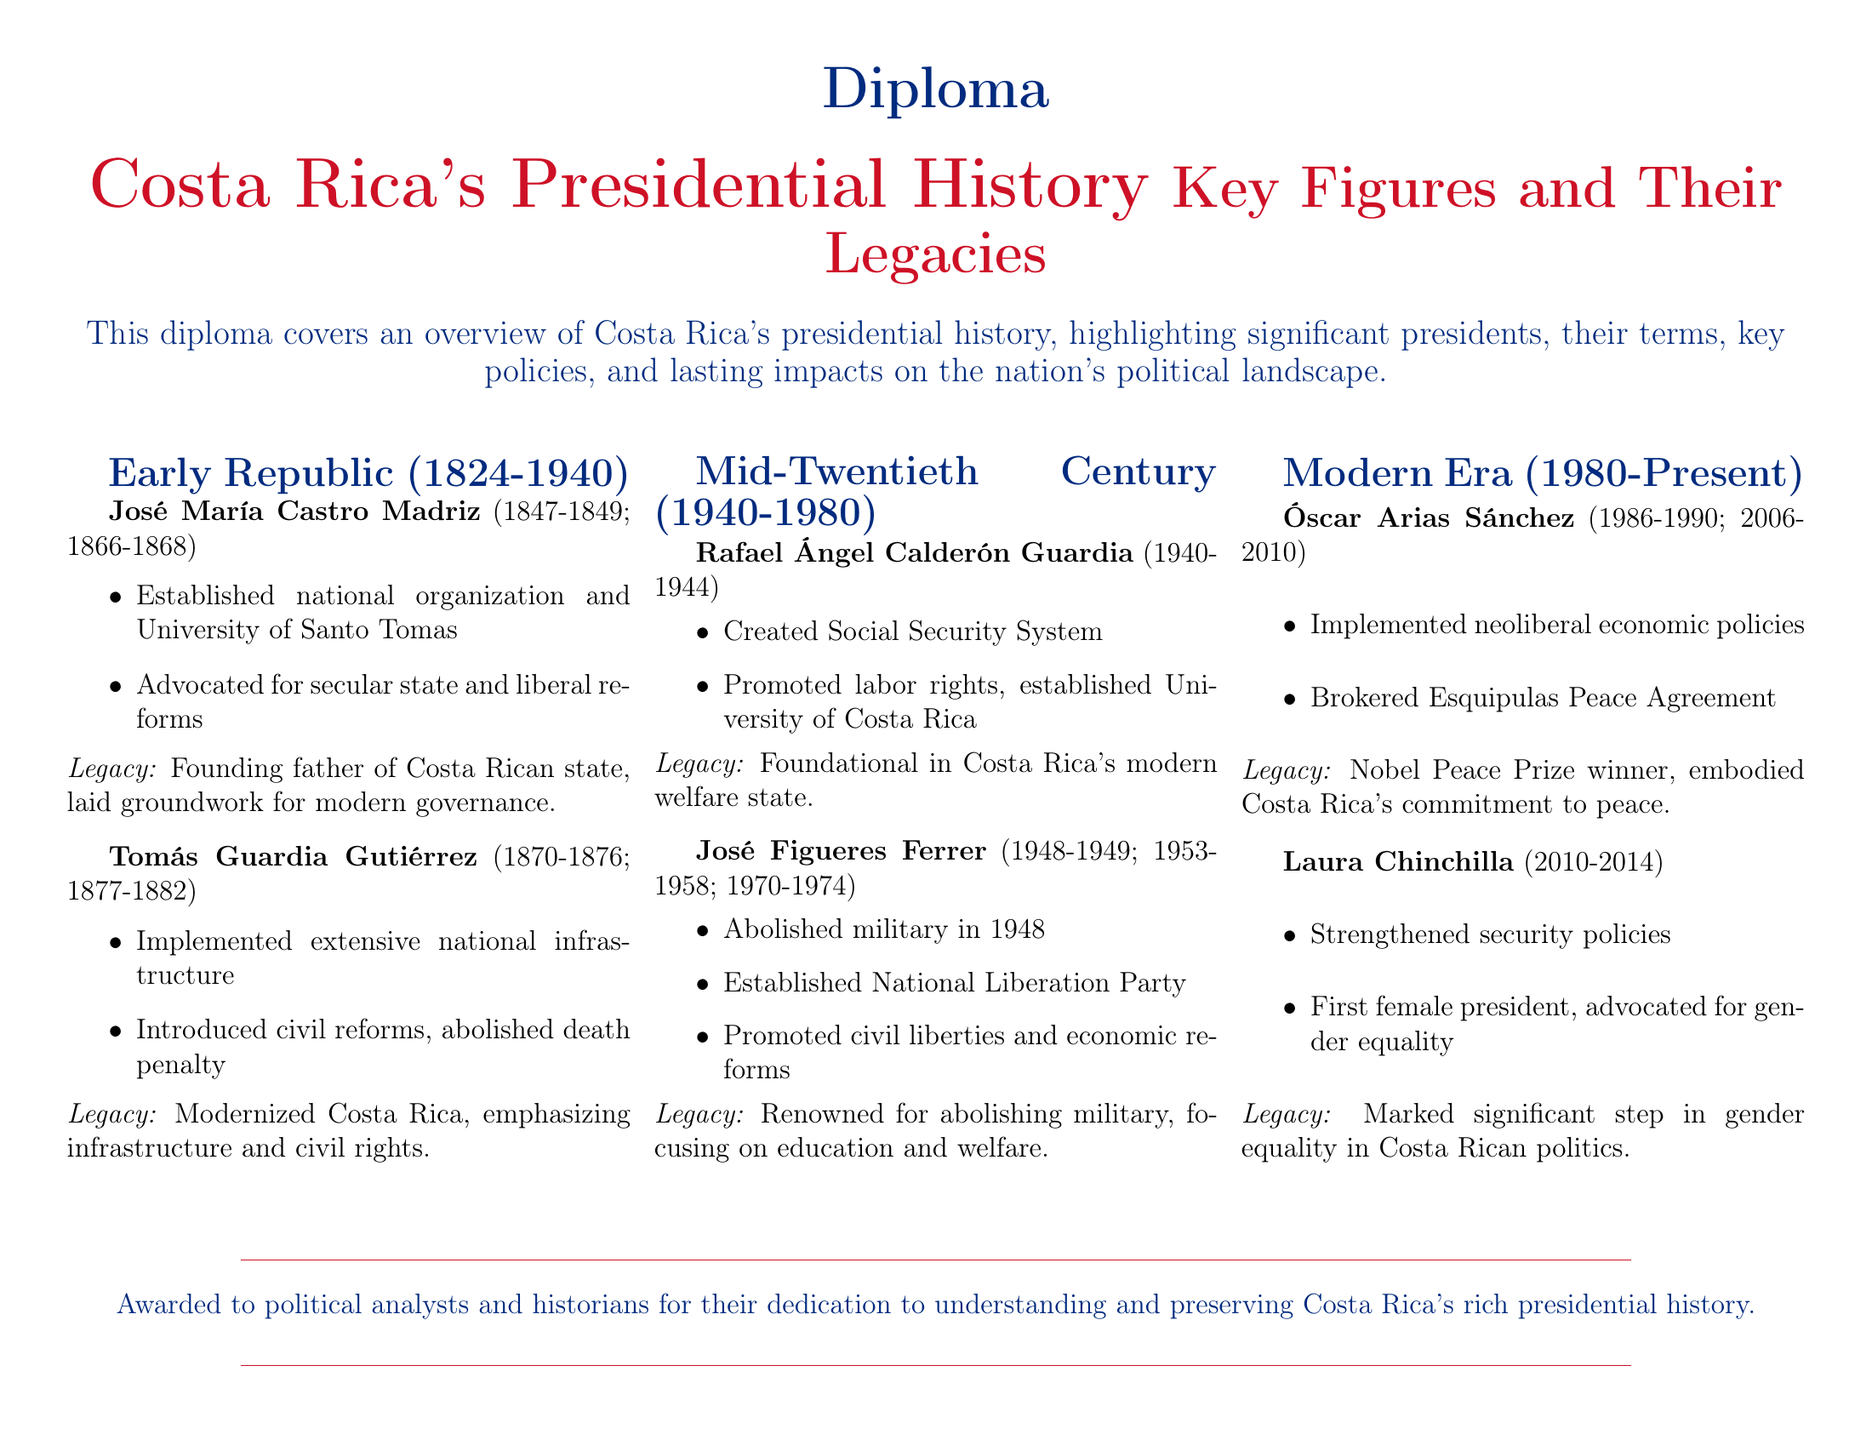what period does the early republic cover? The early republic span is specified in the document as 1824 to 1940.
Answer: 1824-1940 who was the first female president of Costa Rica? The document mentions Laura Chinchilla as the first female president.
Answer: Laura Chinchilla which president established the University of Costa Rica? The document attributes the establishment of the University of Costa Rica to Rafael Ángel Calderón Guardia.
Answer: Rafael Ángel Calderón Guardia how many terms did José Figueres Ferrer serve as president? The document lists several terms for José Figueres Ferrer, indicating three different times he served as president.
Answer: Three what major reform did José María Castro Madriz advocate for? The document states that José María Castro Madriz advocated for a secular state and liberal reforms.
Answer: Secular state and liberal reforms which president is recognized for abolishing the military? The document notes that José Figueres Ferrer is renowned for abolishing the military in 1948.
Answer: José Figueres Ferrer what significant agreement did Óscar Arias Sánchez broker? The document specifies that Óscar Arias Sánchez brokered the Esquipulas Peace Agreement.
Answer: Esquipulas Peace Agreement what legacy did Tomás Guardia Gutiérrez leave in Costa Rica? Tomás Guardia Gutiérrez is noted for modernizing Costa Rica with an emphasis on infrastructure and civil rights.
Answer: Modernized Costa Rica which era does Laura Chinchilla belong to? The document categorizes Laura Chinchilla's presidency as part of the modern era.
Answer: Modern Era 